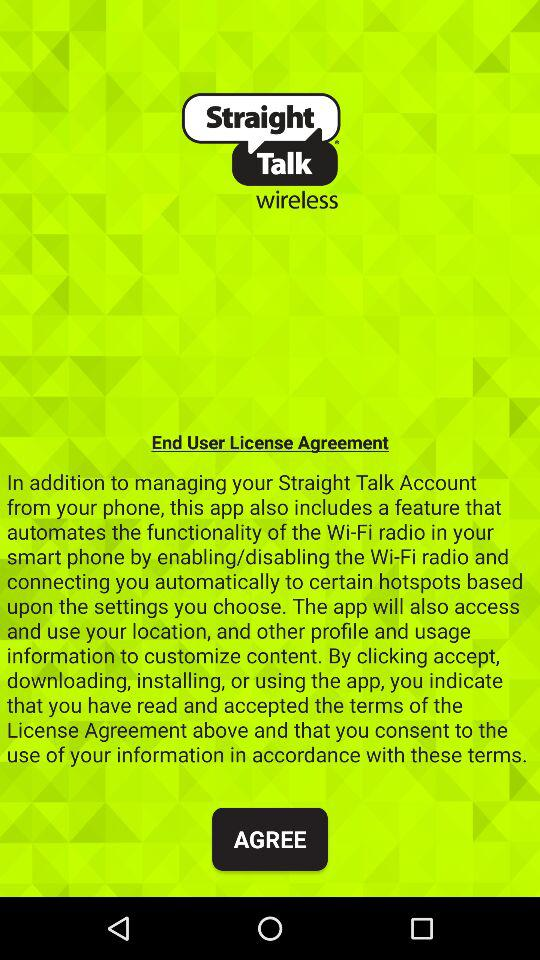What is the application name? The application name is "Straight Talk wireless". 